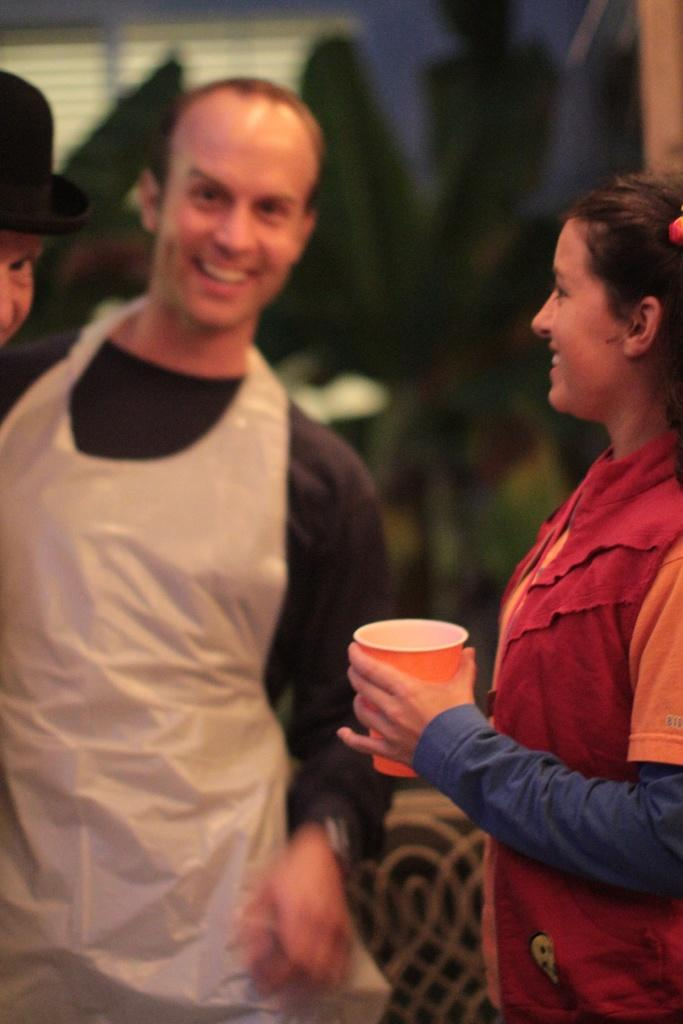What is the woman on the right side of the image doing? The woman is standing on the right side of the image and holding a glass. What can be seen on the left side of the image? There are persons standing on the left side of the image. What is visible in the background of the image? There is a wall in the background of the image. What type of wool is being used by the woman in the image? There is no wool present in the image; the woman is holding a glass. What type of work is being performed by the persons on the left side of the image? The provided facts do not mention any work being performed by the persons on the left side of the image. 